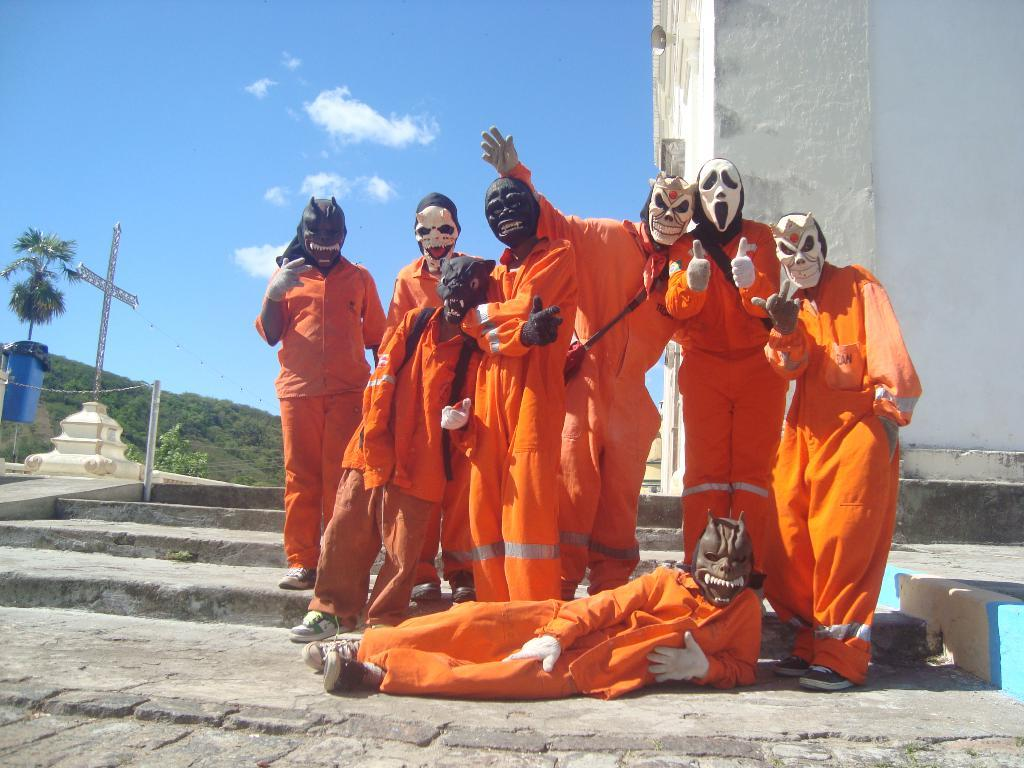What is the main subject of the image? The main subject of the image is a group of people. What are the people wearing in the image? The people are wearing orange dresses. What else can be observed about the people in the image? The people are wearing different types of face masks. What might the group of people be doing in the image? The group of people appear to be taking a photograph. What type of cannon can be seen in the image? There is no cannon present in the image. Can you hear the whistle in the image? The image is a still photograph, so there is no sound or whistle present. 